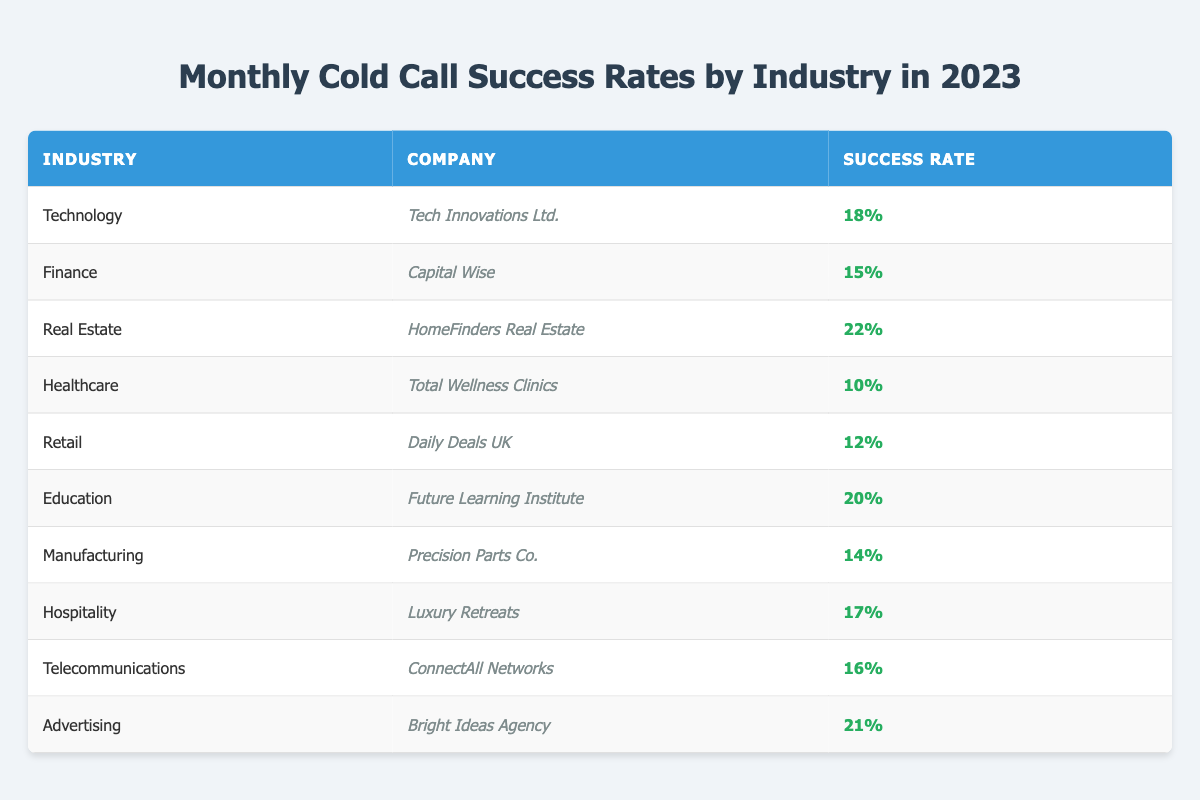What is the success rate for the Real Estate industry? The table indicates that the success rate for the Real Estate industry is listed as 22%.
Answer: 22% Which company in the Technology industry has the highest success rate? The table shows that Tech Innovations Ltd. is the only company mentioned in the Technology industry, with a success rate of 18%.
Answer: Tech Innovations Ltd How many companies have a success rate of 15% or lower? According to the table, there are three companies: Capital Wise (15%), Total Wellness Clinics (10%), and Daily Deals UK (12%).
Answer: 3 What is the average success rate across all industries listed? To find the average, sum all the success rates (18 + 15 + 22 + 10 + 12 + 20 + 14 + 17 + 16 + 21 =  155) and divide by the number of industries (10), resulting in an average of 15.5%.
Answer: 15.5% Is the success rate for Hospitality higher than that of Healthcare? The Hospitality industry has a success rate of 17%, while Healthcare has a success rate of 10%. Since 17% is greater than 10%, the statement is true.
Answer: Yes Which industry has the lowest success rate based on the data? The table indicates that the Healthcare industry has the lowest success rate at 10%.
Answer: Healthcare If we exclude the top two successful industries, what is the success rate of the remaining industries? The top two successful industries are Real Estate (22%) and Advertising (21%). The remaining industries' success rates are (18, 15, 10, 12, 20, 14, 17, 16). Their total is 122, and there are 8 industries, so the average is 122/8 = 15.25%.
Answer: 15.25% How many industries have a success rate of more than 20%? The table shows two industries with success rates above 20%: Real Estate (22%) and Advertising (21%).
Answer: 2 Which company has a success rate closest to the average success rate of 15.5%? The companies closest to the average success rate of 15.5% are Capital Wise (15%) and Manufacturing (14%). Capital Wise is 0.5% below and Manufacturing is 1.5% below the average.
Answer: Capital Wise and Precision Parts Co Is there an industry where the success rate is exactly 16%? Yes, the Telecommunications industry has a success rate of exactly 16%.
Answer: Yes 